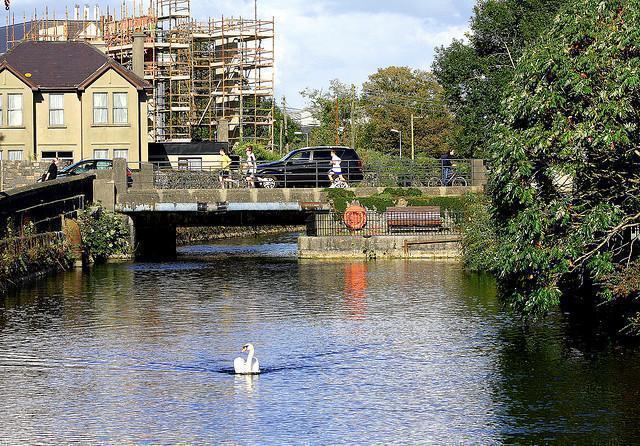Why is he running on the bridge?
Answer the question by selecting the correct answer among the 4 following choices and explain your choice with a short sentence. The answer should be formatted with the following format: `Answer: choice
Rationale: rationale.`
Options: Stay dry, less windy, being followed, shorter run. Answer: stay dry.
Rationale: He appears to be purposely on a run for exercise, and running makes it faster. 